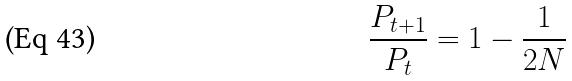Convert formula to latex. <formula><loc_0><loc_0><loc_500><loc_500>\frac { P _ { t + 1 } } { P _ { t } } = 1 - \frac { 1 } { 2 N }</formula> 